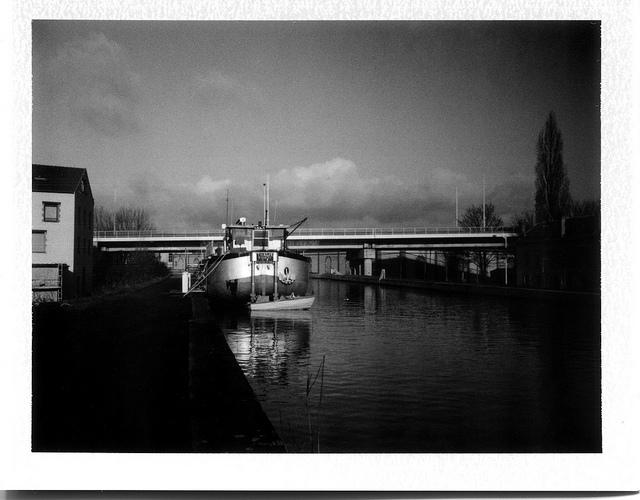How many people in the photo?
Short answer required. 0. Is this a colorful photo?
Give a very brief answer. No. How could you cross the river if you were walking?
Keep it brief. Bridge. 